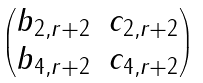<formula> <loc_0><loc_0><loc_500><loc_500>\begin{pmatrix} b _ { 2 , r + 2 } & c _ { 2 , r + 2 } \\ b _ { 4 , r + 2 } & c _ { 4 , r + 2 } \end{pmatrix}</formula> 